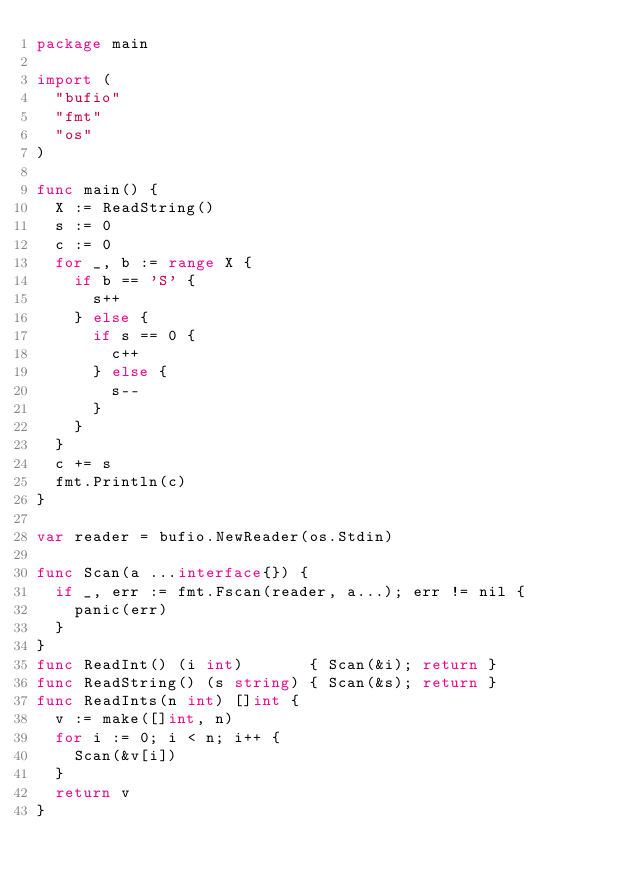<code> <loc_0><loc_0><loc_500><loc_500><_Go_>package main

import (
	"bufio"
	"fmt"
	"os"
)

func main() {
	X := ReadString()
	s := 0
	c := 0
	for _, b := range X {
		if b == 'S' {
			s++
		} else {
			if s == 0 {
				c++
			} else {
				s--
			}
		}
	}
	c += s
	fmt.Println(c)
}

var reader = bufio.NewReader(os.Stdin)

func Scan(a ...interface{}) {
	if _, err := fmt.Fscan(reader, a...); err != nil {
		panic(err)
	}
}
func ReadInt() (i int)       { Scan(&i); return }
func ReadString() (s string) { Scan(&s); return }
func ReadInts(n int) []int {
	v := make([]int, n)
	for i := 0; i < n; i++ {
		Scan(&v[i])
	}
	return v
}
</code> 